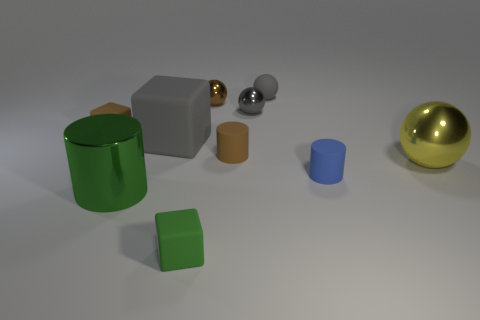Subtract all tiny matte blocks. How many blocks are left? 1 Subtract 3 cubes. How many cubes are left? 0 Subtract all gray balls. How many balls are left? 2 Subtract all cylinders. How many objects are left? 7 Add 1 cylinders. How many cylinders exist? 4 Subtract 1 green cylinders. How many objects are left? 9 Subtract all blue balls. Subtract all cyan blocks. How many balls are left? 4 Subtract all blue spheres. How many brown blocks are left? 1 Subtract all brown balls. Subtract all blocks. How many objects are left? 6 Add 1 green metal cylinders. How many green metal cylinders are left? 2 